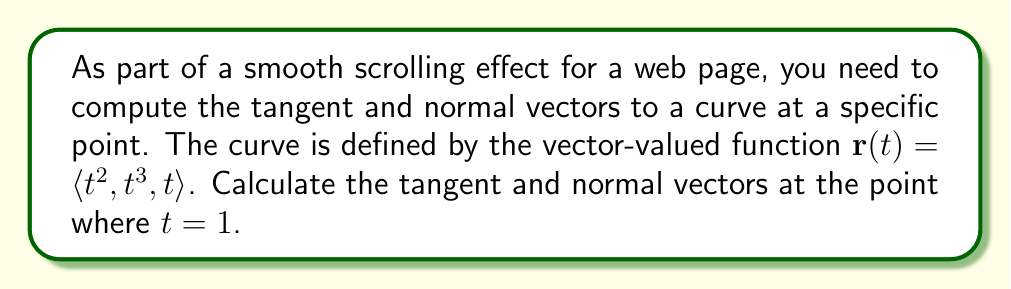Could you help me with this problem? To solve this problem, we'll follow these steps:

1. Find the tangent vector:
   The tangent vector is given by the derivative of the position vector $\mathbf{r}(t)$.
   
   $$\mathbf{r}'(t) = \langle 2t, 3t^2, 1 \rangle$$
   
   At $t = 1$:
   $$\mathbf{r}'(1) = \langle 2, 3, 1 \rangle$$

   This is our tangent vector, but we usually normalize it to get a unit tangent vector:
   
   $$\mathbf{T} = \frac{\mathbf{r}'(1)}{\|\mathbf{r}'(1)\|} = \frac{\langle 2, 3, 1 \rangle}{\sqrt{2^2 + 3^2 + 1^2}} = \frac{\langle 2, 3, 1 \rangle}{\sqrt{14}}$$

2. Find the normal vector:
   To find the normal vector, we need to calculate the second derivative of $\mathbf{r}(t)$.
   
   $$\mathbf{r}''(t) = \langle 2, 6t, 0 \rangle$$
   
   At $t = 1$:
   $$\mathbf{r}''(1) = \langle 2, 6, 0 \rangle$$

   The normal vector is the component of $\mathbf{r}''(t)$ that's perpendicular to $\mathbf{T}$. We can find this using the formula:

   $$\mathbf{N} = \frac{\mathbf{r}''(1) - (\mathbf{r}''(1) \cdot \mathbf{T})\mathbf{T}}{\|\mathbf{r}''(1) - (\mathbf{r}''(1) \cdot \mathbf{T})\mathbf{T}\|}$$

   First, let's calculate $\mathbf{r}''(1) \cdot \mathbf{T}$:
   
   $$\mathbf{r}''(1) \cdot \mathbf{T} = \langle 2, 6, 0 \rangle \cdot \frac{\langle 2, 3, 1 \rangle}{\sqrt{14}} = \frac{2(2) + 6(3) + 0(1)}{\sqrt{14}} = \frac{22}{\sqrt{14}}$$

   Now we can calculate the numerator of $\mathbf{N}$:

   $$\mathbf{r}''(1) - (\mathbf{r}''(1) \cdot \mathbf{T})\mathbf{T} = \langle 2, 6, 0 \rangle - \frac{22}{\sqrt{14}} \cdot \frac{\langle 2, 3, 1 \rangle}{\sqrt{14}}$$
   
   $$= \langle 2, 6, 0 \rangle - \frac{22}{14} \langle 2, 3, 1 \rangle = \langle 2 - \frac{44}{14}, 6 - \frac{66}{14}, 0 - \frac{22}{14} \rangle$$
   
   $$= \langle \frac{-16}{14}, \frac{18}{14}, \frac{-22}{14} \rangle = \frac{\langle -8, 9, -11 \rangle}{7}$$

   The magnitude of this vector is:

   $$\sqrt{(-8)^2 + 9^2 + (-11)^2} / 7 = \sqrt{282} / 7$$

   Therefore, the unit normal vector is:

   $$\mathbf{N} = \frac{\langle -8, 9, -11 \rangle}{7} \cdot \frac{7}{\sqrt{282}} = \frac{\langle -8, 9, -11 \rangle}{\sqrt{282}}$$
Answer: Tangent vector: $\mathbf{T} = \frac{\langle 2, 3, 1 \rangle}{\sqrt{14}}$

Normal vector: $\mathbf{N} = \frac{\langle -8, 9, -11 \rangle}{\sqrt{282}}$ 